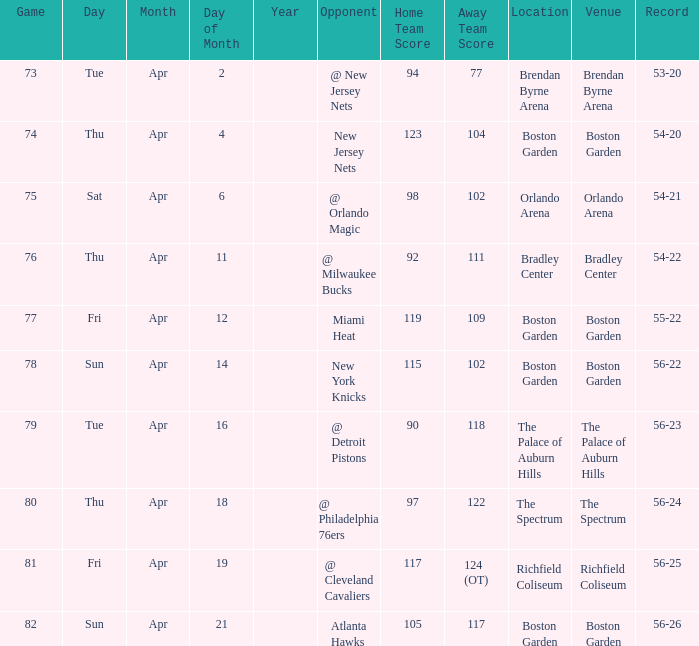When was the score 56-26? Sun. Apr. 21. 